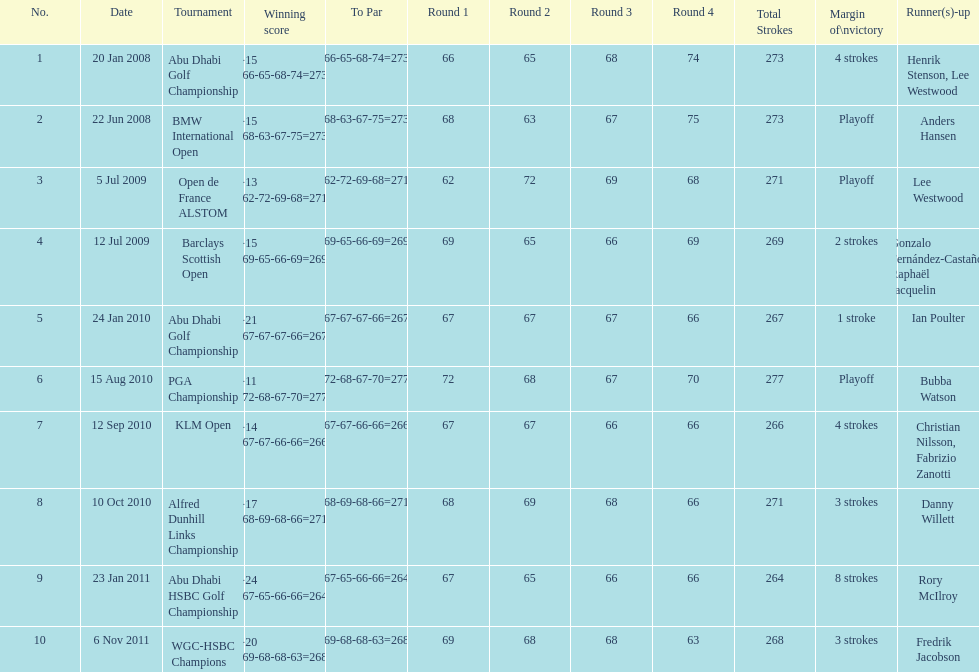How many winning scores were less than -14? 2. 